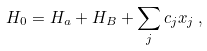<formula> <loc_0><loc_0><loc_500><loc_500>H _ { 0 } = H _ { a } + H _ { B } + \sum _ { j } c _ { j } x _ { j } \, ,</formula> 